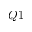<formula> <loc_0><loc_0><loc_500><loc_500>Q 1</formula> 